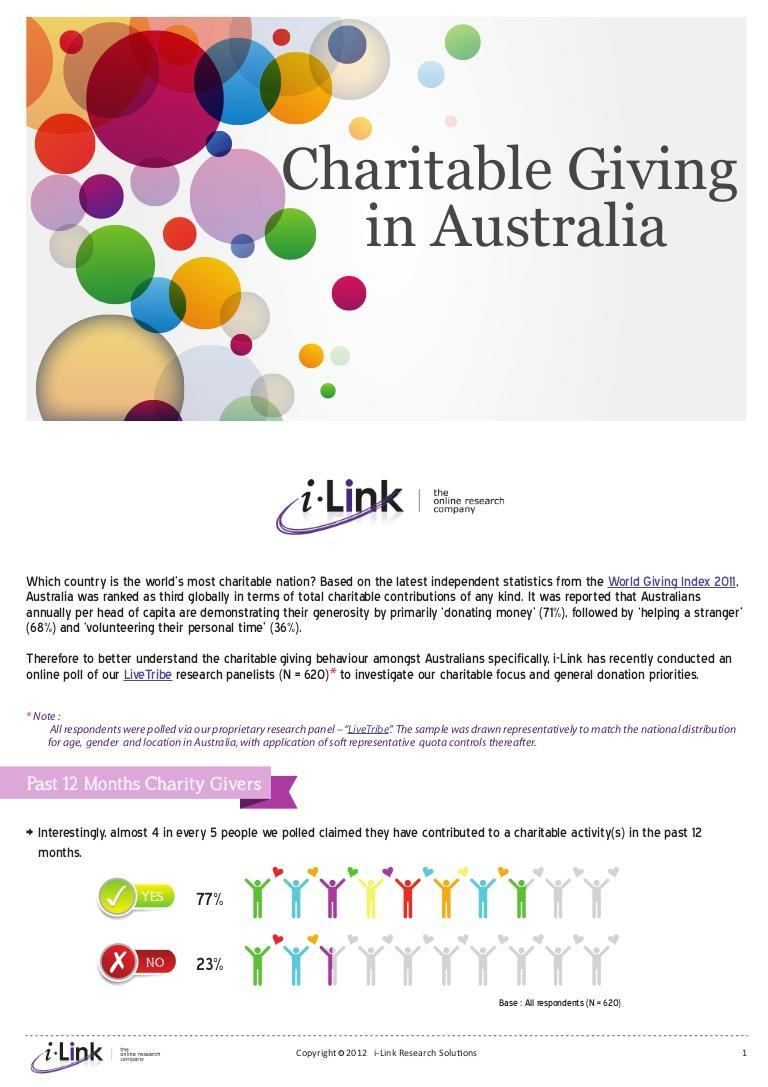What is the percentage of people who have contributed to charity in the last year?
Answer the question with a short phrase. 77% What percentage of people have not contributed to charity during the last year? 23% 